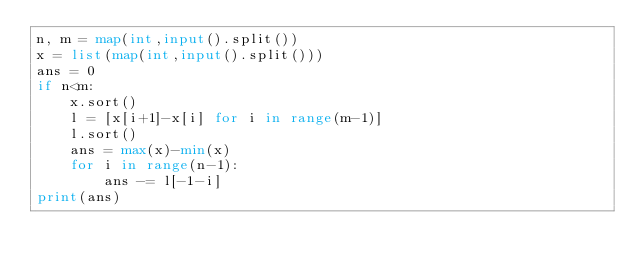<code> <loc_0><loc_0><loc_500><loc_500><_Python_>n, m = map(int,input().split())
x = list(map(int,input().split()))
ans = 0
if n<m:
    x.sort()
    l = [x[i+1]-x[i] for i in range(m-1)]
    l.sort()
    ans = max(x)-min(x)
    for i in range(n-1):
        ans -= l[-1-i]
print(ans)</code> 